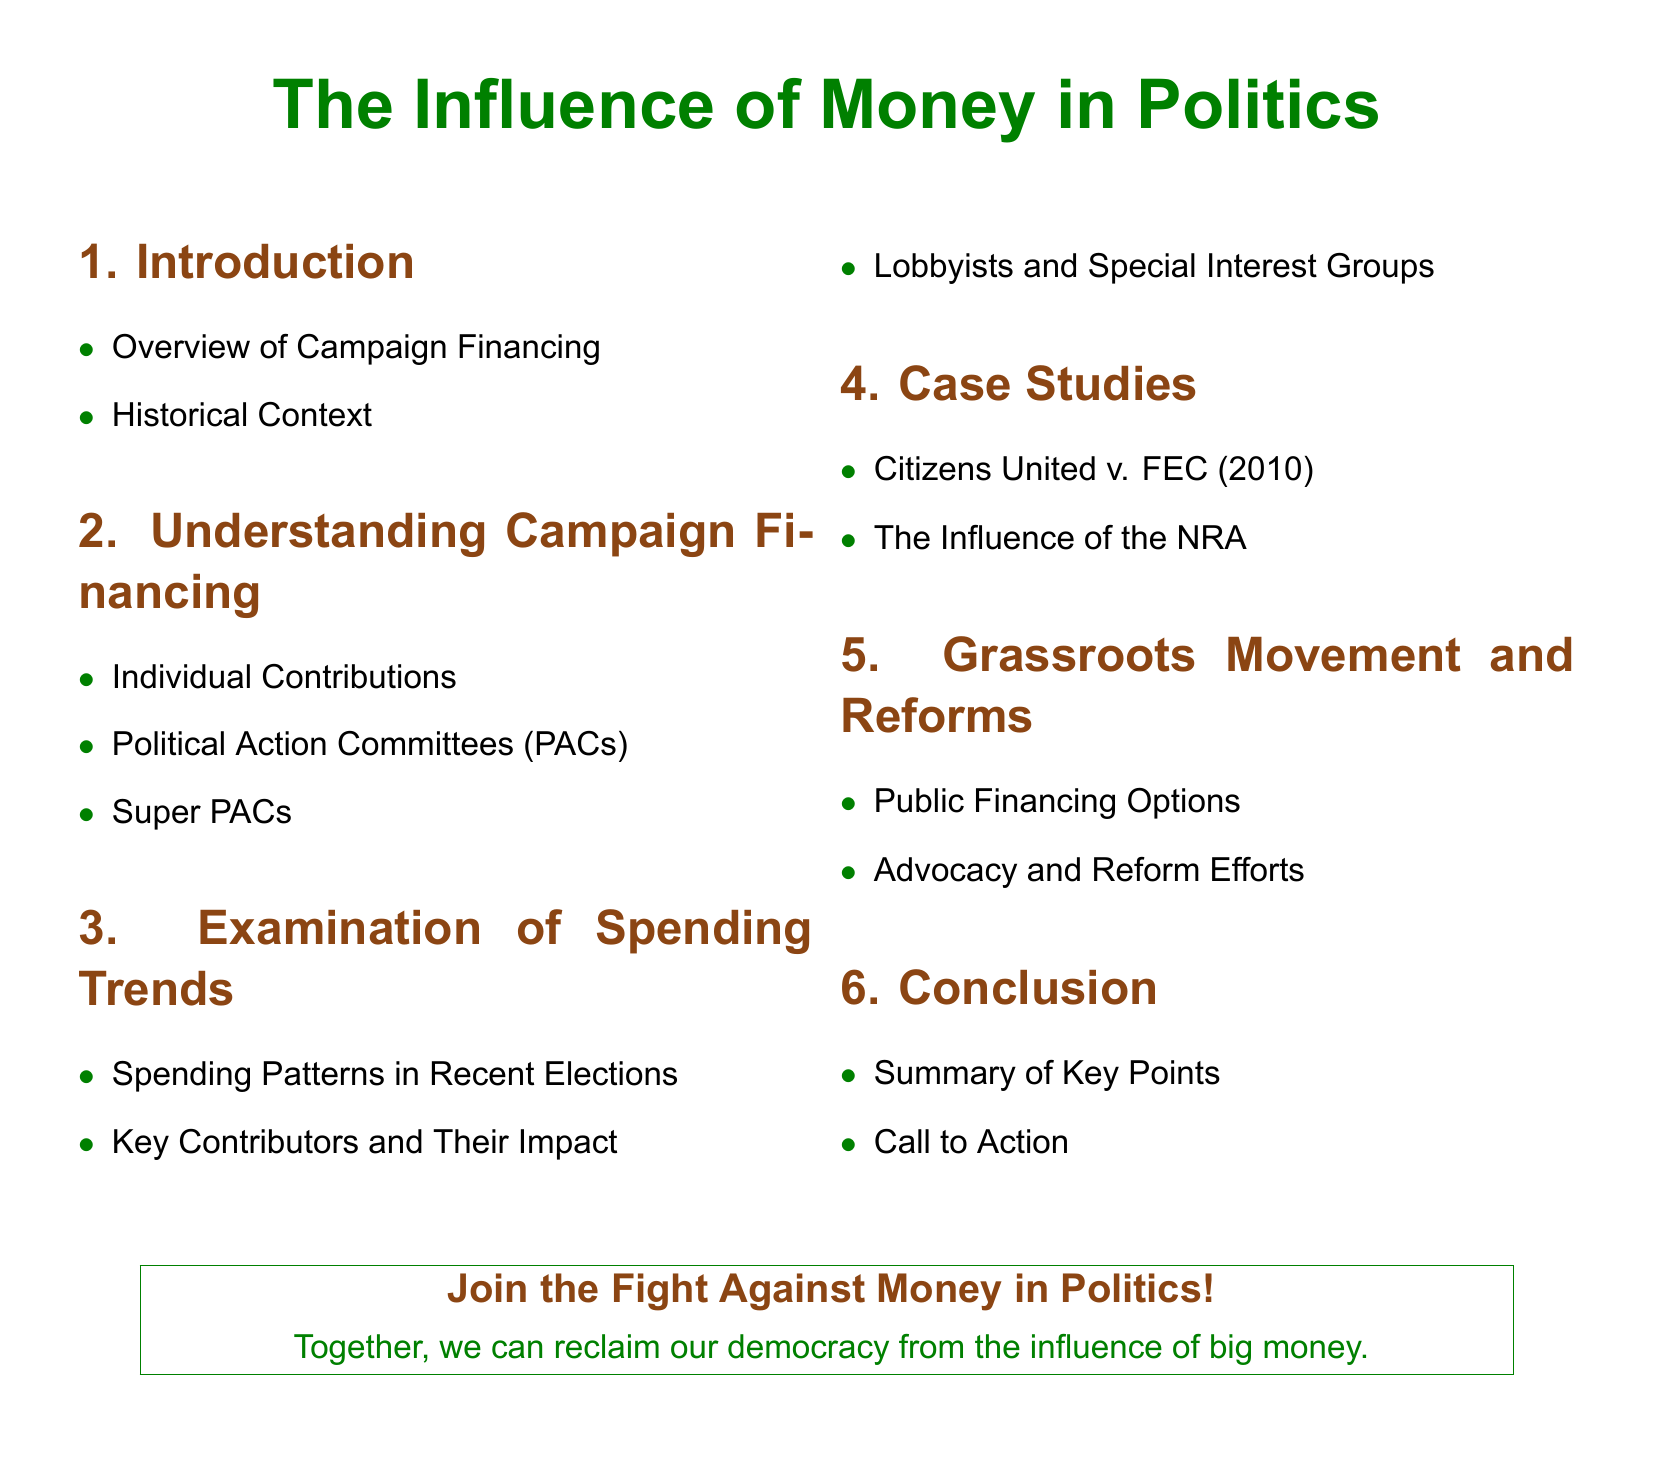What is the title of the document? The title is stated prominently at the top of the document.
Answer: The Influence of Money in Politics How many sections are there in the document? Each section is listed in the table of contents.
Answer: Six What court case is mentioned in the case studies? The court case is highlighted in the case studies section.
Answer: Citizens United v. FEC What color is used for the section titles? The document specifies a color that represents the section headings.
Answer: Activist brown What is one of the topics under Understanding Campaign Financing? The subtopics are listed under the second section of the document.
Answer: Political Action Committees (PACs) What is the main call to action in the conclusion? The conclusion section emphasizes a collective movement against a specific issue.
Answer: Join the Fight Against Money in Politics! 